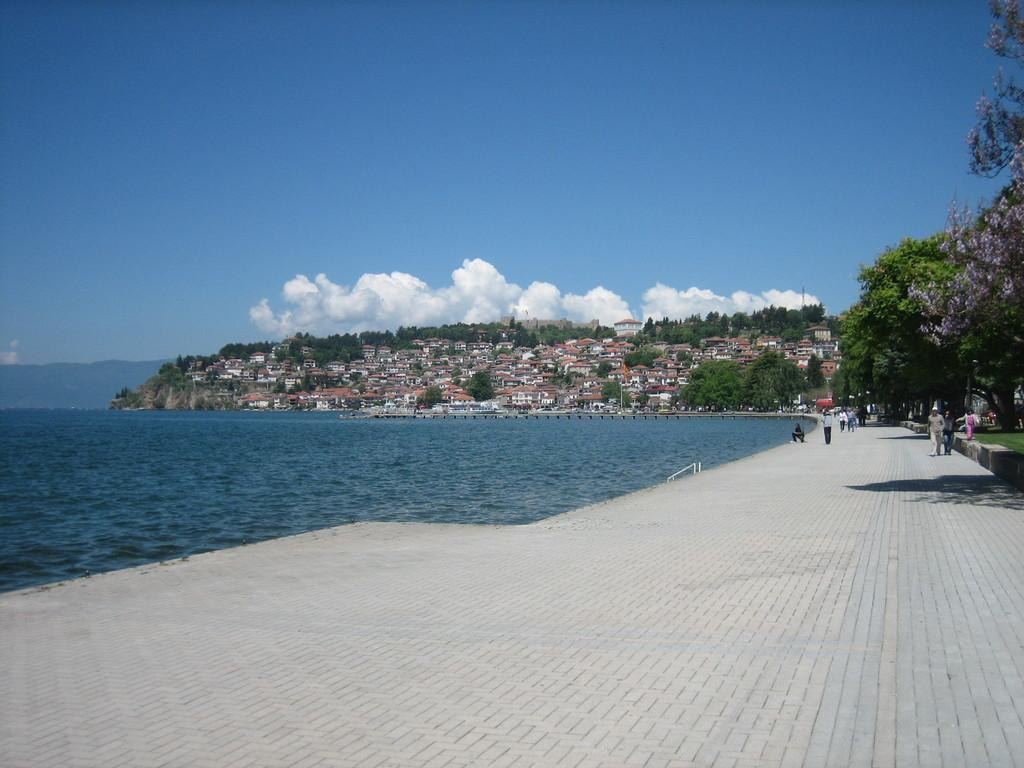How many people are in the image? There is a group of people in the image. What is visible in the image besides the people? Water, trees, houses, hills, and the sky are visible in the image. Can you describe the landscape in the image? The image features water, trees, houses, and hills, with the sky visible in the background. What type of desk is being used by the father in the image? There is no father or desk present in the image. 